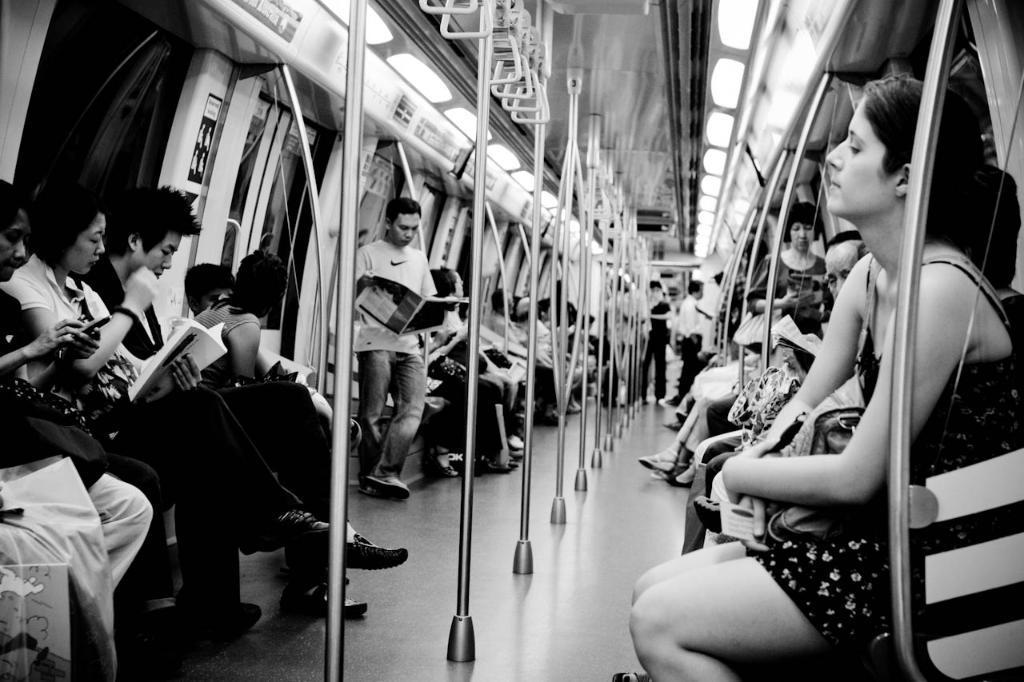Please provide a concise description of this image. In this picture we can see a metro rail where we can see a group of people some are sitting and standing. In front we can see a woman sitting and holding her bag on left side we can see a man reading newspaper and here woman sitting and reading book and the woman she is watching the mobile and in middle we can see some rods and hangers to hold and in the background we can see some windows. 